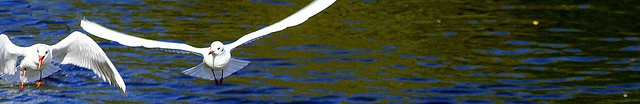Describe the objects in this image and their specific colors. I can see bird in blue, white, darkgray, and gray tones and bird in blue, white, and gray tones in this image. 